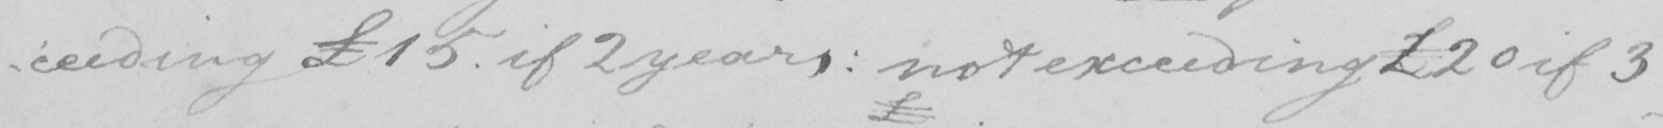Transcribe the text shown in this historical manuscript line. -ceeding £15 . if 2 years :  not exceeding £20 if 3 